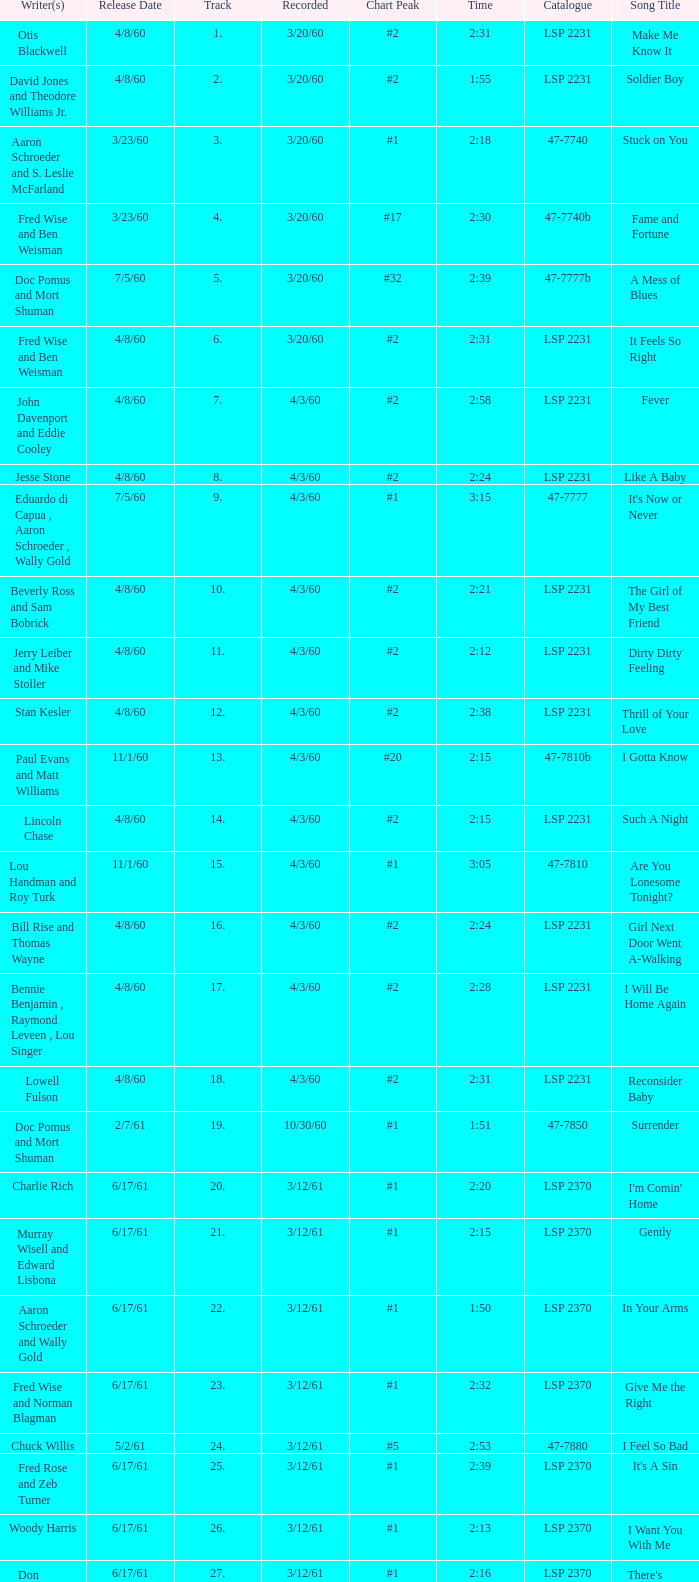On songs that have a release date of 6/17/61, a track larger than 20, and a writer of Woody Harris, what is the chart peak? #1. 